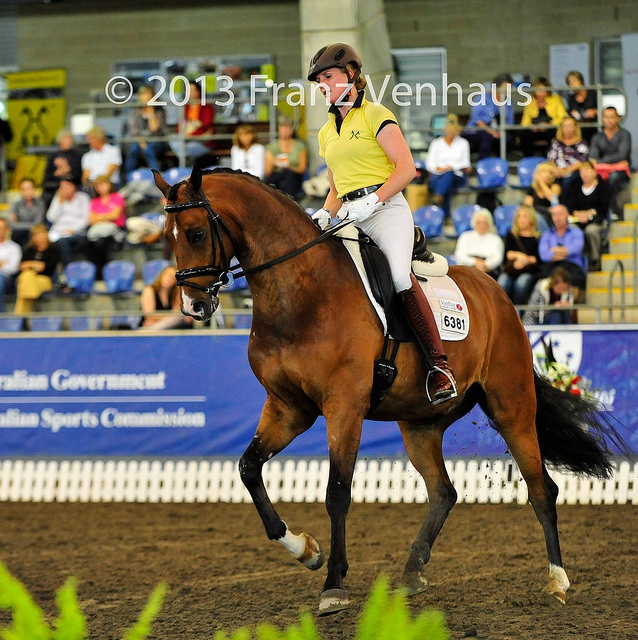Describe the objects in this image and their specific colors. I can see horse in black, maroon, and brown tones, people in black, gray, white, and olive tones, people in black, khaki, lightgray, and tan tones, people in black, tan, olive, and darkgray tones, and people in black, lightgray, darkgray, and gray tones in this image. 